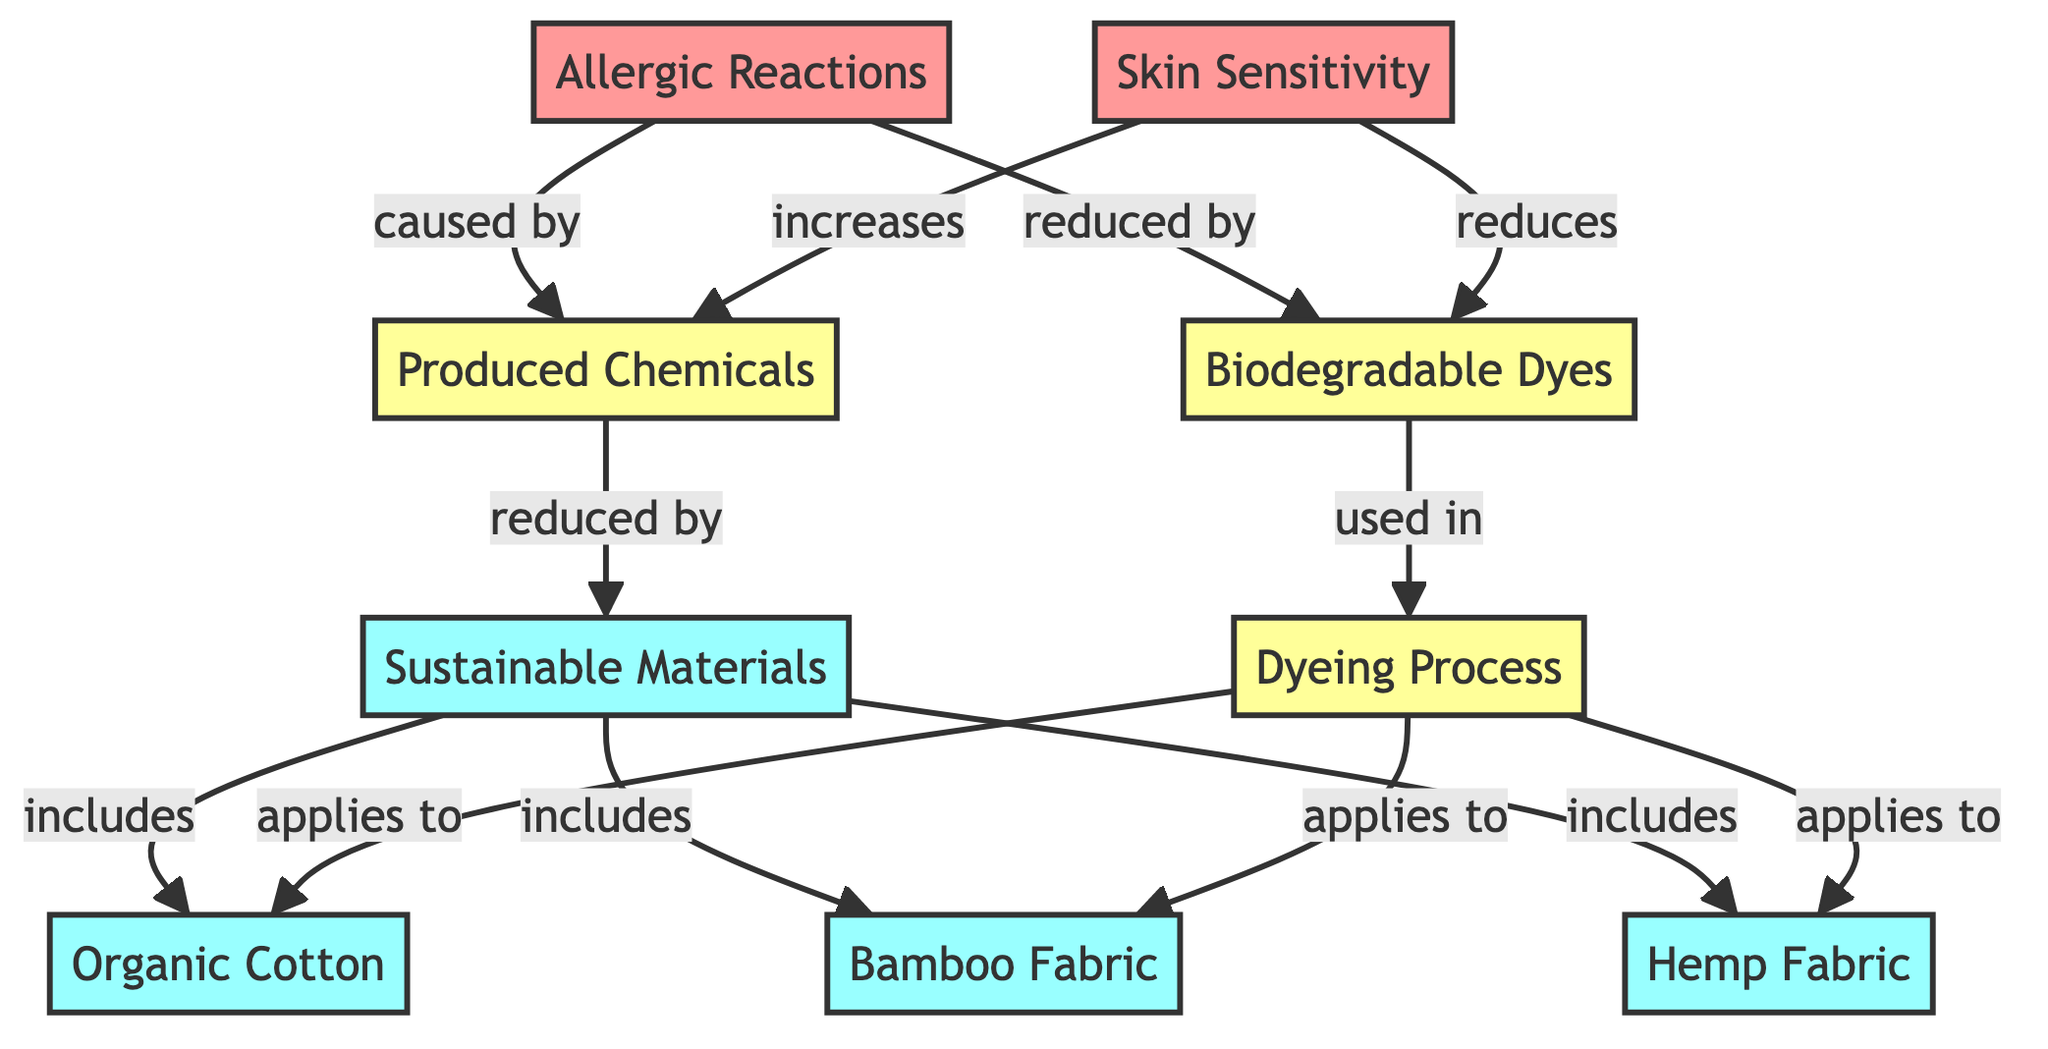What is included in sustainable materials? The diagram explicitly states that sustainable materials include organic cotton, bamboo fabric, and hemp fabric. Therefore, the answer lists all these materials.
Answer: organic cotton, bamboo fabric, hemp fabric What effect do biodegradable dyes have on allergic reactions? According to the diagram, biodegradable dyes are stated to reduce allergic reactions. This indicates a direct positive effect on those reactions.
Answer: reduced How many sustainable material types are represented in the diagram? The diagram shows three types of sustainable materials: organic cotton, bamboo fabric, and hemp fabric. Counting these gives a total of three types.
Answer: 3 Which process applies to all sustainable materials listed? The dyeing process is shown in the diagram to apply to organic cotton, bamboo fabric, and hemp fabric, indicating a common processing method among them.
Answer: dyeing process What effect do produced chemicals have on skin sensitivity? The diagram indicates that produced chemicals increase skin sensitivity, showing a negative relationship between produced chemicals and skin health.
Answer: increases What is used in the dyeing process? The diagram specifies that biodegradable dyes are used in the dyeing process, highlighting the materials employed within that stage.
Answer: biodegradable dyes Explain the relationship between produced chemicals and allergic reactions. The diagram illustrates that allergic reactions are caused by produced chemicals, signifying a direct cause-and-effect relationship where one leads to the other.
Answer: caused by How do sustainable materials affect produced chemicals? It is indicated in the diagram that sustainable materials reduce produced chemicals, which suggests that using these materials can lead to a decrease in harmful substances.
Answer: reduced by What is the overall effect of biodegradable dyes on skin sensitivity? The diagram shows that biodegradable dyes reduce skin sensitivity, presenting a beneficial outcome when these dyes are used in textiles.
Answer: reduces 